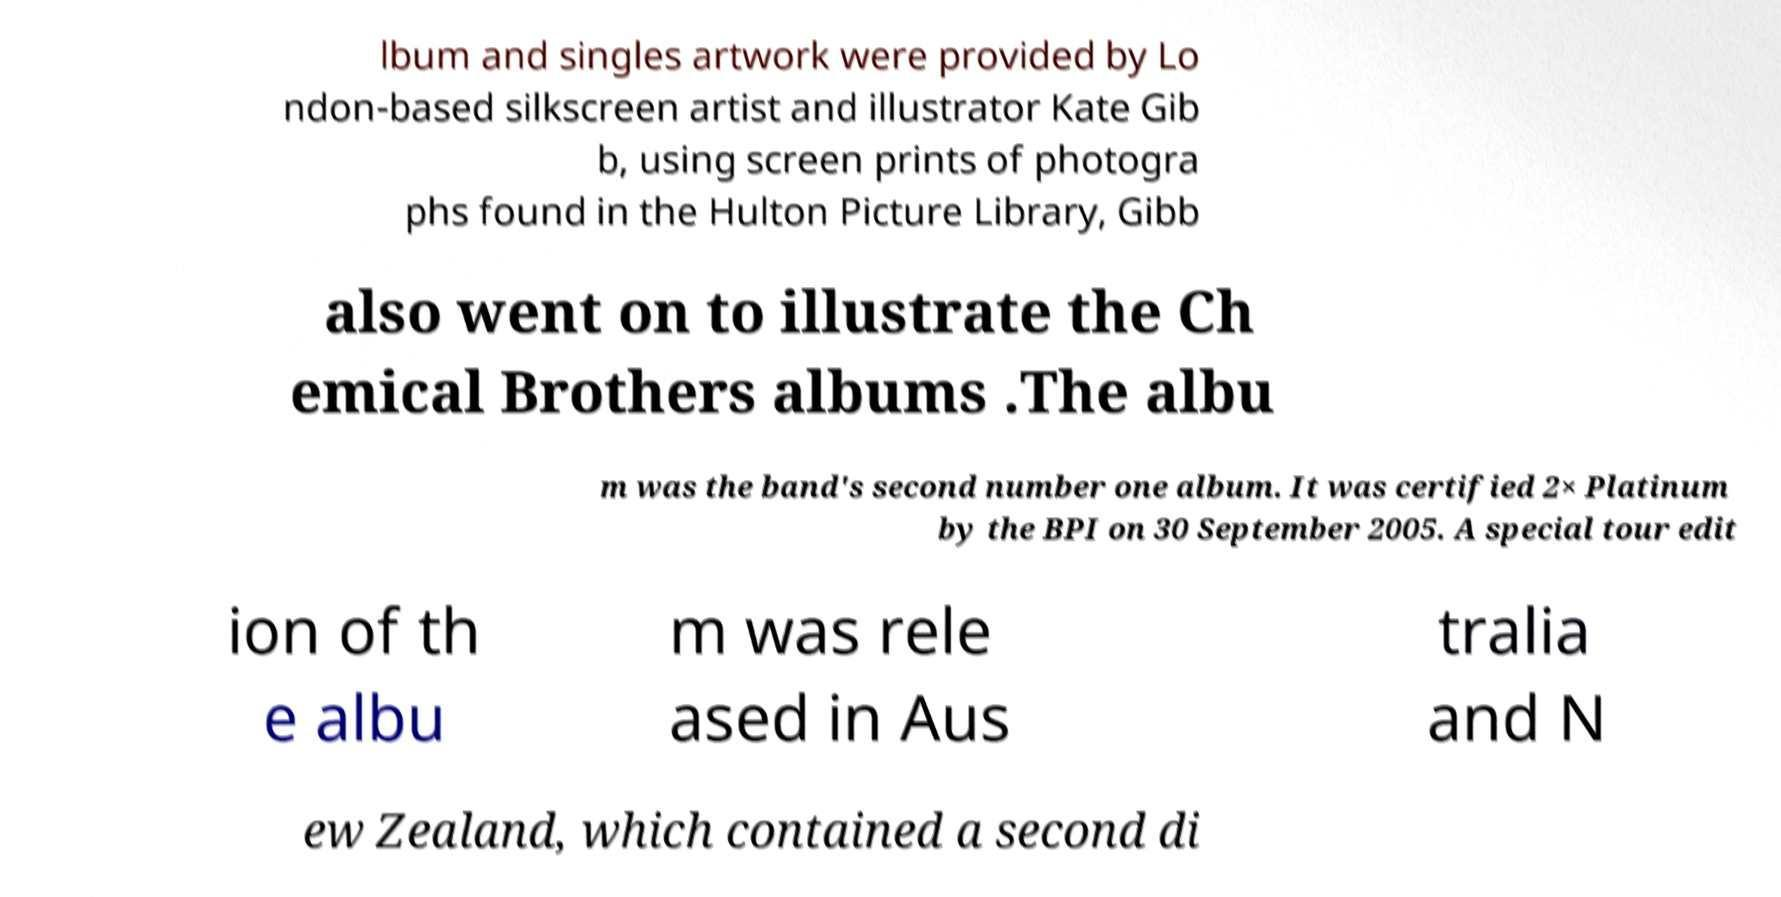Can you accurately transcribe the text from the provided image for me? lbum and singles artwork were provided by Lo ndon-based silkscreen artist and illustrator Kate Gib b, using screen prints of photogra phs found in the Hulton Picture Library, Gibb also went on to illustrate the Ch emical Brothers albums .The albu m was the band's second number one album. It was certified 2× Platinum by the BPI on 30 September 2005. A special tour edit ion of th e albu m was rele ased in Aus tralia and N ew Zealand, which contained a second di 